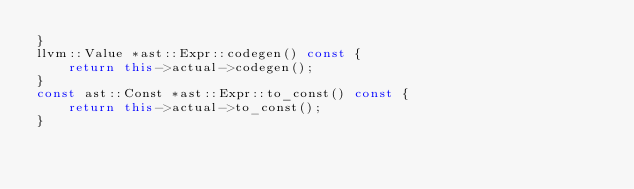Convert code to text. <code><loc_0><loc_0><loc_500><loc_500><_C++_>}
llvm::Value *ast::Expr::codegen() const {
    return this->actual->codegen();
}
const ast::Const *ast::Expr::to_const() const {
    return this->actual->to_const();
}</code> 